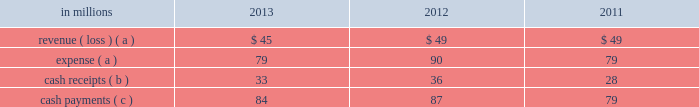Is downgraded below a specified threshold , the new bank is required to provide credit support for its obligation .
Fees of $ 5 million were incurred in connection with this replacement .
On november 29 , 2011 , standard and poor's reduced its credit rating of senior unsecured long-term debt of lloyds tsb bank plc , which issued letters of credit that support $ 1.2 billion of the timber notes , below the specified threshold .
The letters of credit were successfully replaced by another qualifying institution .
Fees of $ 4 million were incurred in connection with this replacement .
On january 23 , 2012 , standard and poor's reduced its credit rating of senior unsecured long-term debt of soci e9t e9 g e9n e9rale sa , which issued letters of credit that support $ 666 million of the timber notes , below the specified threshold .
The letters of credit were successfully replaced by another qualifying institution .
Fees of $ 5 million were incurred in connection with this replacement .
On june 21 , 2012 , moody's investor services reduced its credit rating of senior unsecured long-term debt of bnp paribas , which issued letters of credit that support $ 707 million of timber notes , below the specified threshold .
On december 19 , 2012 , the company and the third-party managing member agreed to a continuing replacement waiver for these letters of credit , terminable upon 30 days notice .
Activity between the company and the entities was as follows: .
( a ) the net expense related to the company 2019s interest in the entities is included in interest expense , net in the accompanying consolidated statement of operations , as international paper has and intends to effect its legal right to offset as discussed above .
( b ) the cash receipts are equity distributions from the entities to international paper .
( c ) the semi-annual payments are related to interest on the associated debt obligations discussed above .
Based on an analysis of the entities discussed above under guidance that considers the potential magnitude of the variability in the structures and which party has a controlling financial interest , international paper determined that it is not the primary beneficiary of the entities , and therefore , should not consolidate its investments in these entities .
It was also determined that the source of variability in the structure is the value of the timber notes , the assets most significantly impacting the structure 2019s economic performance .
The credit quality of the timber notes is supported by irrevocable letters of credit obtained by third-party buyers which are 100% ( 100 % ) cash collateralized .
International paper analyzed which party has control over the economic performance of each entity , and concluded international paper does not have control over significant decisions surrounding the timber notes and letters of credit and therefore is not the primary beneficiary .
The company 2019s maximum exposure to loss equals the value of the timber notes ; however , an analysis performed by the company concluded the likelihood of this exposure is remote .
International paper also held variable interests in two financing entities that were used to monetize long-term notes received from the sale of forestlands in 2001 and 2002 .
International paper transferred notes ( the monetized notes , with an original maturity of 10 years from inception ) and cash of approximately $ 1.0 billion to these entities in exchange for preferred interests , and accounted for the transfers as a sale of the notes with no associated gain or loss .
In the same period , the entities acquired approximately $ 1.0 billion of international paper debt obligations for cash .
International paper has no obligation to make any further capital contributions to these entities and did not provide any financial support that was not previously contractually required during the years ended december 31 , 2013 , 2012 or 2011 .
The 2001 monetized notes of $ 499 million matured on march 16 , 2011 .
Following their maturity , international paper purchased the class a preferred interest in the 2001 financing entities from an external third-party for $ 21 million .
As a result of the purchase , effective march 16 , 2011 , international paper owned 100% ( 100 % ) of the 2001 financing entities .
Based on an analysis performed by the company after the purchase , under guidance that considers the potential magnitude of the variability in the structure and which party has a controlling financial interest , international paper determined that it was the primary beneficiary of the 2001 financing entities and thus consolidated the entities effective march 16 , 2011 .
Effective april 30 , 2011 , international paper liquidated its interest in the 2001 financing entities .
Activity between the company and the 2001 financing entities during 2011 was immaterial. .
Based on the review of the activity between the company and the entities what was the ratio of the revenue to expense in 2013? 
Computations: (45 / 79)
Answer: 0.56962. 